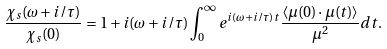Convert formula to latex. <formula><loc_0><loc_0><loc_500><loc_500>\frac { \chi _ { s } ( \omega + i / \tau ) } { \chi _ { s } ( 0 ) } = 1 + i ( \omega + i / \tau ) \int _ { 0 } ^ { \infty } e ^ { i ( \omega + i / \tau ) t } \frac { \langle { \mu } ( 0 ) \cdot { \mu } ( t ) \rangle } { \mu ^ { 2 } } d t .</formula> 